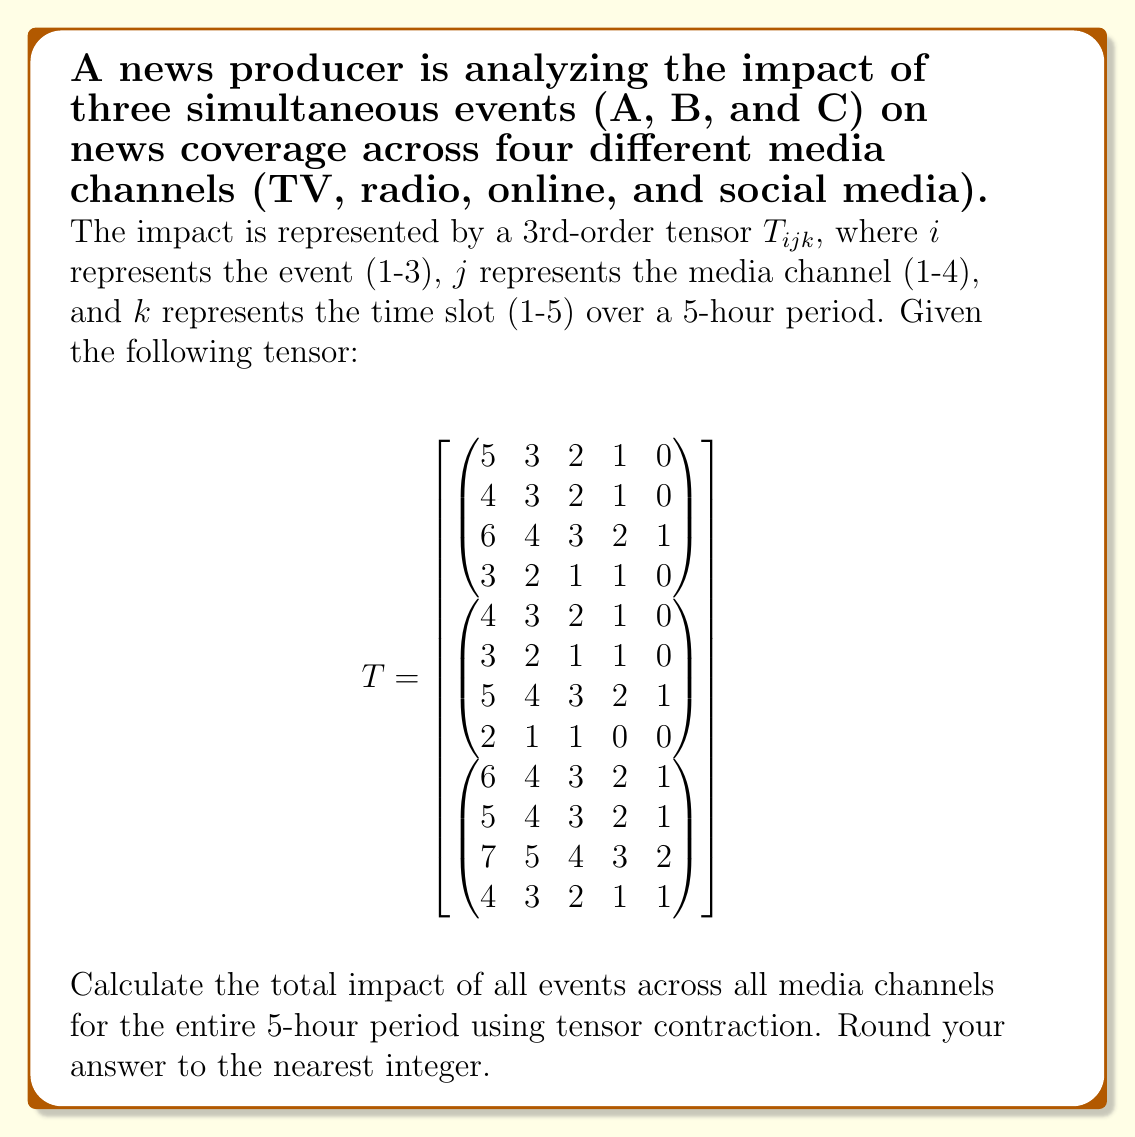What is the answer to this math problem? To solve this problem, we need to perform tensor contraction on the given 3rd-order tensor. This will sum up all the elements across all dimensions, giving us the total impact of all events across all media channels for the entire 5-hour period.

Step 1: Understand the tensor dimensions
- $i$ (1-3): represents the 3 events (A, B, C)
- $j$ (1-4): represents the 4 media channels (TV, radio, online, social media)
- $k$ (1-5): represents the 5 time slots

Step 2: Set up the tensor contraction
The tensor contraction can be represented as:

$$\sum_{i=1}^3 \sum_{j=1}^4 \sum_{k=1}^5 T_{ijk}$$

Step 3: Calculate the sum for each event (i)

Event A (i=1):
$$(5+3+2+1+0) + (4+3+2+1+0) + (6+4+3+2+1) + (3+2+1+1+0) = 43$$

Event B (i=2):
$$(4+3+2+1+0) + (3+2+1+1+0) + (5+4+3+2+1) + (2+1+1+0+0) = 35$$

Event C (i=3):
$$(6+4+3+2+1) + (5+4+3+2+1) + (7+5+4+3+2) + (4+3+2+1+1) = 62$$

Step 4: Sum up the results from all events
Total impact = 43 + 35 + 62 = 140

Step 5: Round to the nearest integer
The result is already an integer, so no rounding is necessary.
Answer: 140 